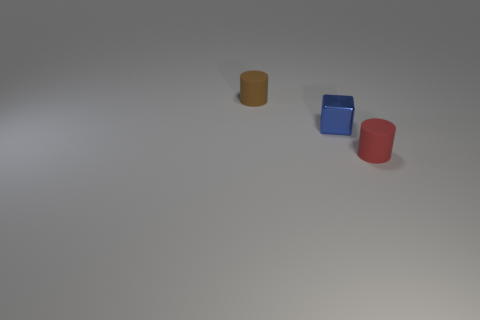Are there any indicators of the size of these objects? While the image doesn't include a common reference object for scale, we can infer their size by looking at the apparent texture of the surface they're on, and their casting shadows. The soft edges of the shadows suggest that the objects are not extremely large since sharper shadows would mean a smaller light source relative to the object size or closer proximity to the surface. Therefore, we might conclude that these could be common desktop items. 